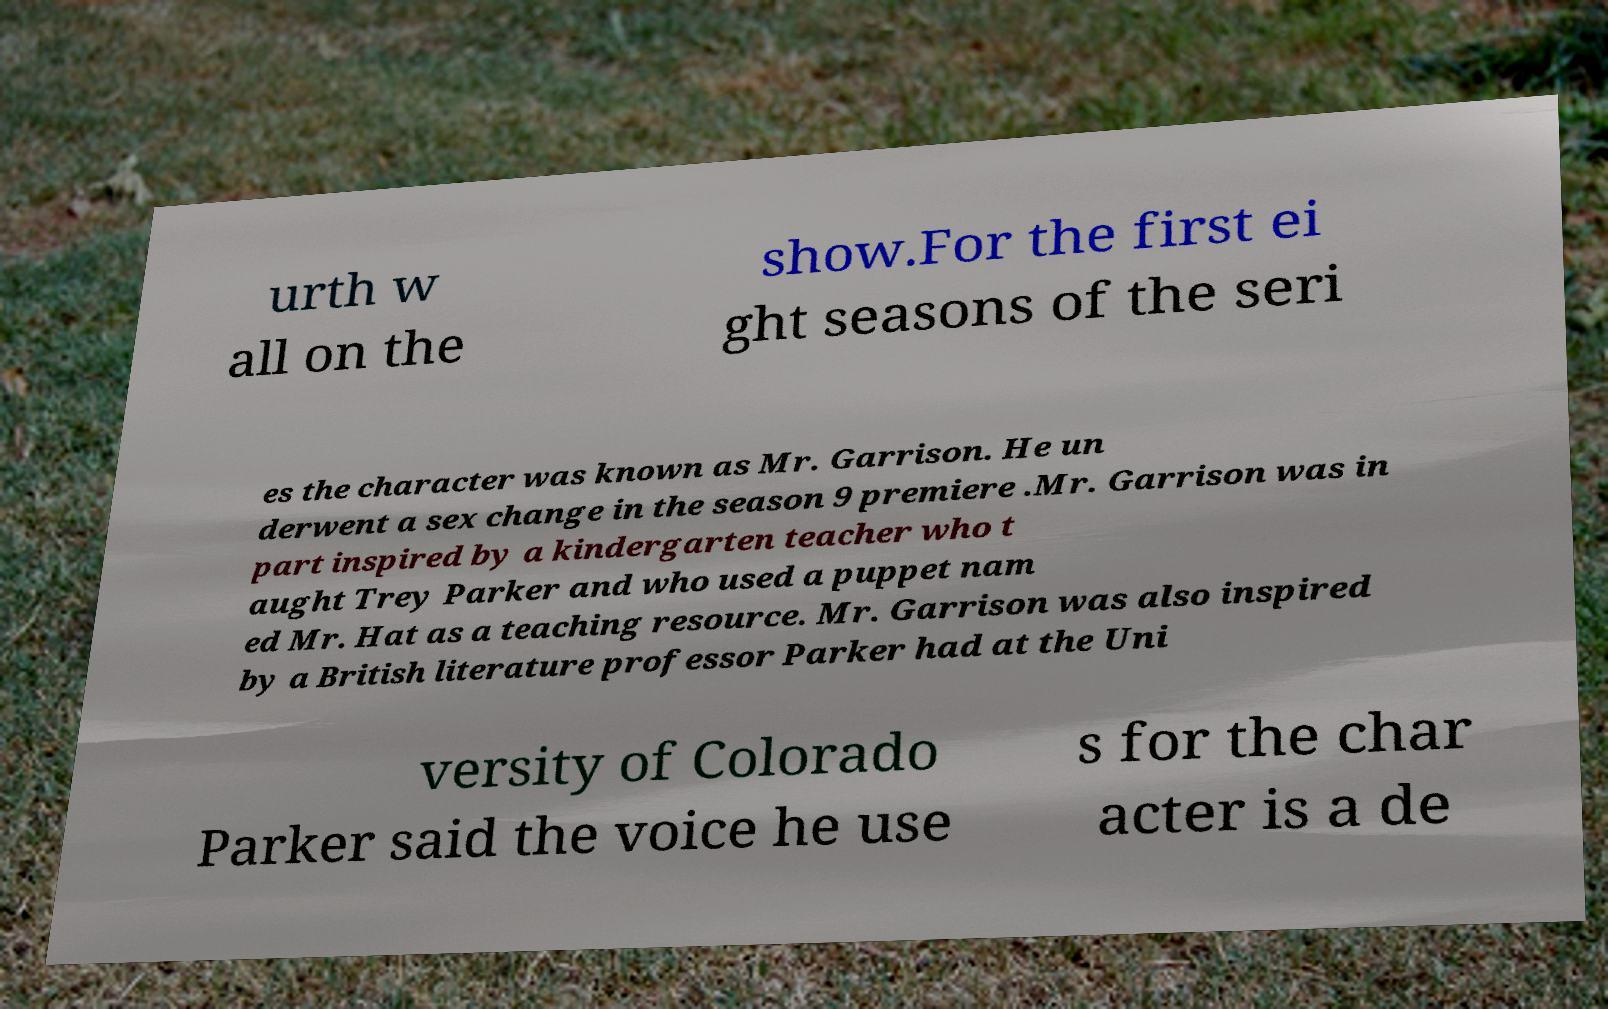Can you accurately transcribe the text from the provided image for me? urth w all on the show.For the first ei ght seasons of the seri es the character was known as Mr. Garrison. He un derwent a sex change in the season 9 premiere .Mr. Garrison was in part inspired by a kindergarten teacher who t aught Trey Parker and who used a puppet nam ed Mr. Hat as a teaching resource. Mr. Garrison was also inspired by a British literature professor Parker had at the Uni versity of Colorado Parker said the voice he use s for the char acter is a de 